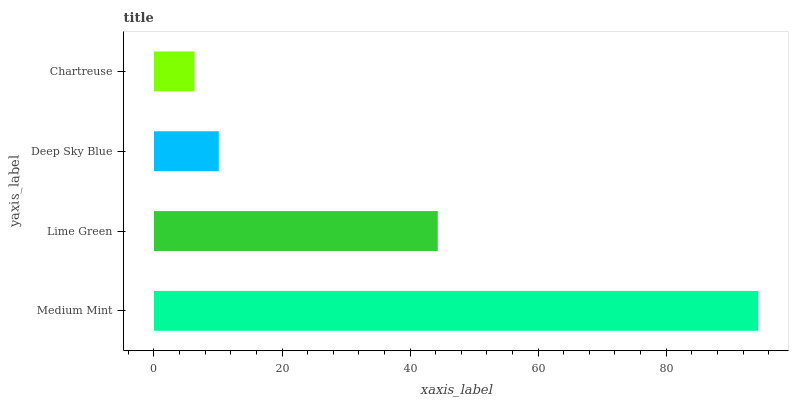Is Chartreuse the minimum?
Answer yes or no. Yes. Is Medium Mint the maximum?
Answer yes or no. Yes. Is Lime Green the minimum?
Answer yes or no. No. Is Lime Green the maximum?
Answer yes or no. No. Is Medium Mint greater than Lime Green?
Answer yes or no. Yes. Is Lime Green less than Medium Mint?
Answer yes or no. Yes. Is Lime Green greater than Medium Mint?
Answer yes or no. No. Is Medium Mint less than Lime Green?
Answer yes or no. No. Is Lime Green the high median?
Answer yes or no. Yes. Is Deep Sky Blue the low median?
Answer yes or no. Yes. Is Deep Sky Blue the high median?
Answer yes or no. No. Is Medium Mint the low median?
Answer yes or no. No. 